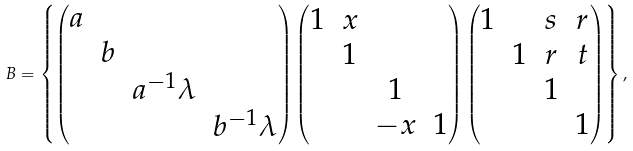<formula> <loc_0><loc_0><loc_500><loc_500>B = \left \{ \begin{pmatrix} a \\ & b \\ & & a ^ { - 1 } \lambda \\ & & & b ^ { - 1 } \lambda \end{pmatrix} \begin{pmatrix} 1 & x \\ & 1 \\ & & 1 & \\ & & - x & 1 \end{pmatrix} \begin{pmatrix} 1 & & s & r \\ & 1 & r & t \\ & & 1 \\ & & & 1 \end{pmatrix} \right \} ,</formula> 